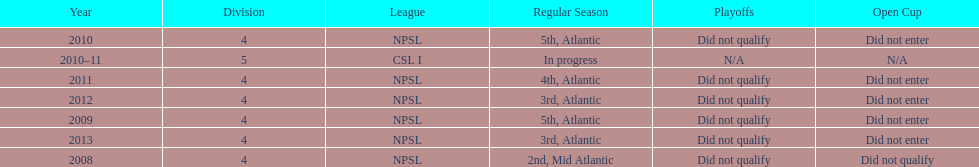Which year was more successful, 2010 or 2013? 2013. Could you parse the entire table as a dict? {'header': ['Year', 'Division', 'League', 'Regular Season', 'Playoffs', 'Open Cup'], 'rows': [['2010', '4', 'NPSL', '5th, Atlantic', 'Did not qualify', 'Did not enter'], ['2010–11', '5', 'CSL I', 'In progress', 'N/A', 'N/A'], ['2011', '4', 'NPSL', '4th, Atlantic', 'Did not qualify', 'Did not enter'], ['2012', '4', 'NPSL', '3rd, Atlantic', 'Did not qualify', 'Did not enter'], ['2009', '4', 'NPSL', '5th, Atlantic', 'Did not qualify', 'Did not enter'], ['2013', '4', 'NPSL', '3rd, Atlantic', 'Did not qualify', 'Did not enter'], ['2008', '4', 'NPSL', '2nd, Mid Atlantic', 'Did not qualify', 'Did not qualify']]} 